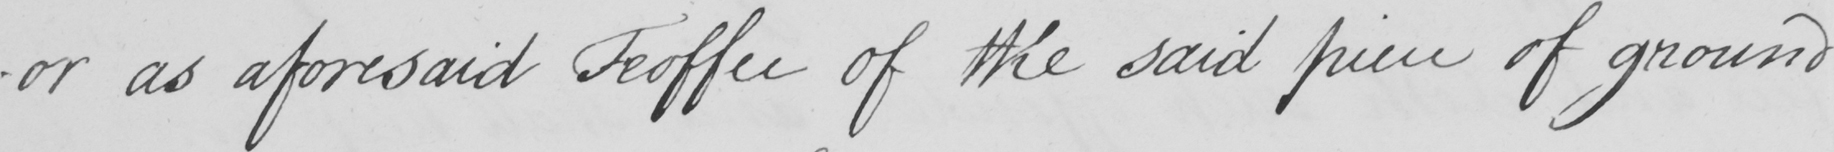Please provide the text content of this handwritten line. -or as aforesaid Feoffee of the said piece of ground 